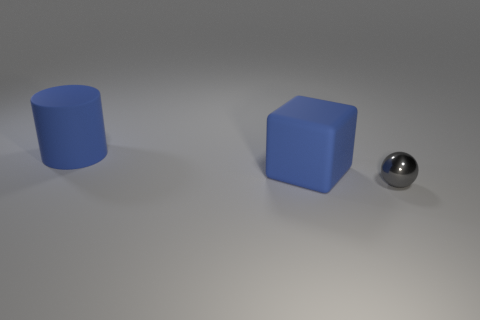Is the size of the blue object right of the cylinder the same as the cylinder?
Offer a terse response. Yes. There is a big cylinder; does it have the same color as the rubber object that is in front of the large cylinder?
Your answer should be compact. Yes. The matte thing that is the same color as the cylinder is what shape?
Your response must be concise. Cube. The tiny metal object has what shape?
Give a very brief answer. Sphere. Is the large rubber block the same color as the shiny thing?
Ensure brevity in your answer.  No. What number of things are either big blue things that are on the left side of the cube or gray things?
Keep it short and to the point. 2. What size is the blue cylinder that is the same material as the cube?
Offer a very short reply. Large. Are there more things that are in front of the tiny gray ball than tiny matte cylinders?
Your answer should be very brief. No. Is the shape of the metal thing the same as the blue rubber thing to the right of the rubber cylinder?
Offer a very short reply. No. What number of small things are yellow metallic objects or blue rubber things?
Ensure brevity in your answer.  0. 